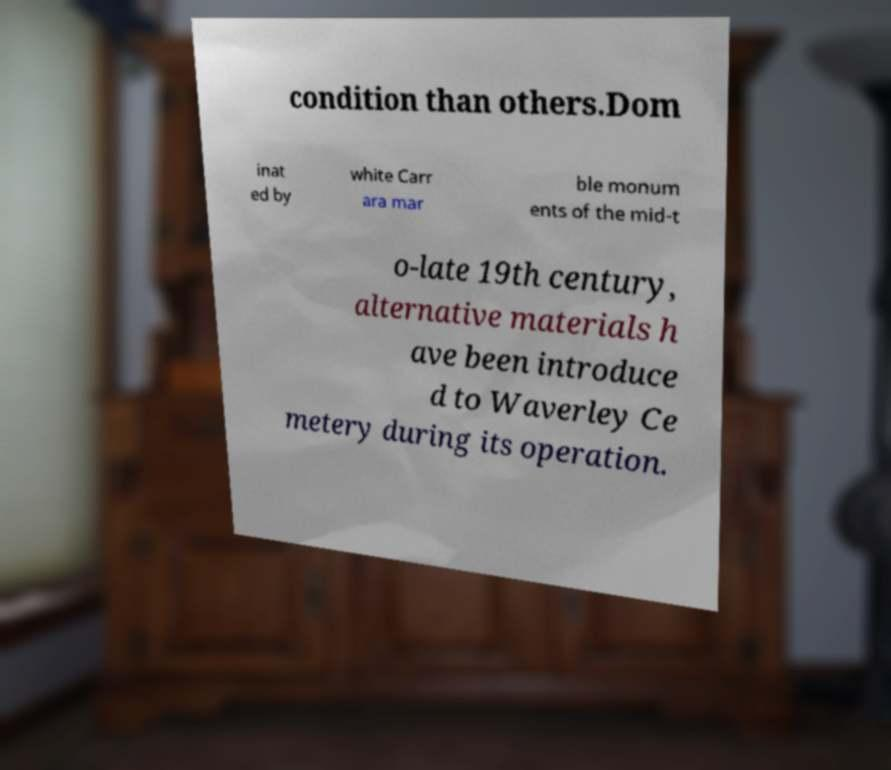I need the written content from this picture converted into text. Can you do that? condition than others.Dom inat ed by white Carr ara mar ble monum ents of the mid-t o-late 19th century, alternative materials h ave been introduce d to Waverley Ce metery during its operation. 